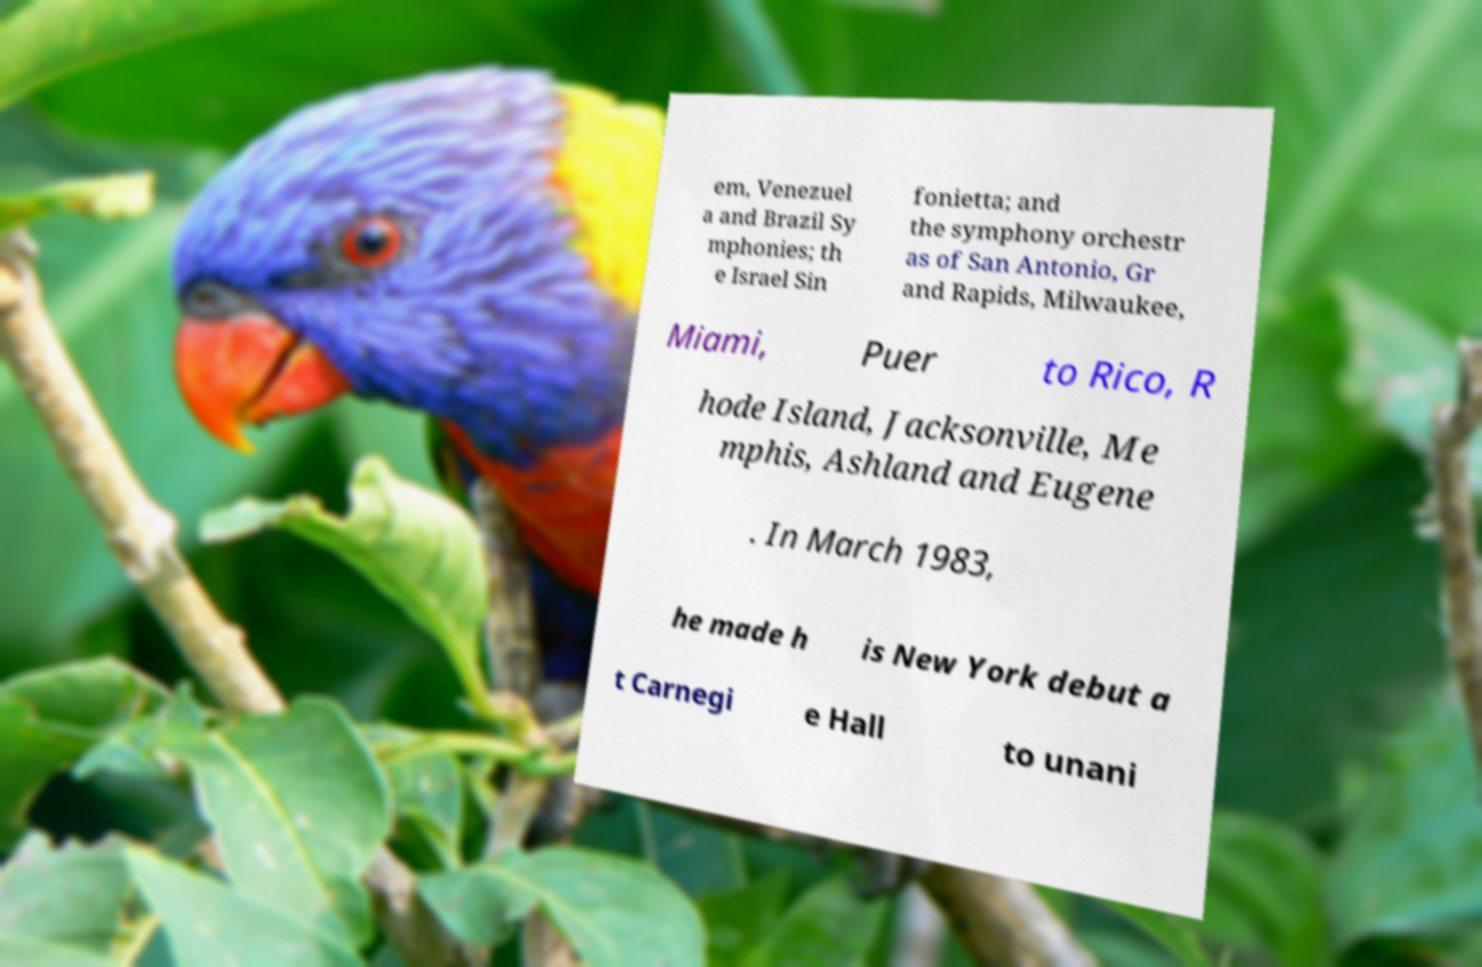Please identify and transcribe the text found in this image. em, Venezuel a and Brazil Sy mphonies; th e Israel Sin fonietta; and the symphony orchestr as of San Antonio, Gr and Rapids, Milwaukee, Miami, Puer to Rico, R hode Island, Jacksonville, Me mphis, Ashland and Eugene . In March 1983, he made h is New York debut a t Carnegi e Hall to unani 